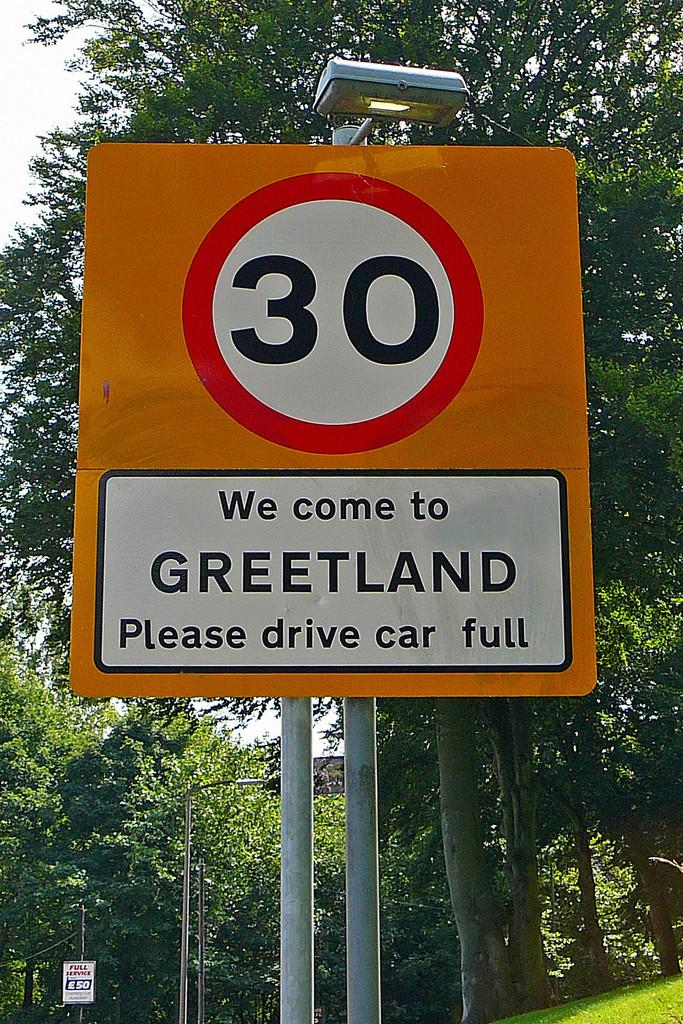<image>
Give a short and clear explanation of the subsequent image. A sign with the number 30 and Greetland on it 